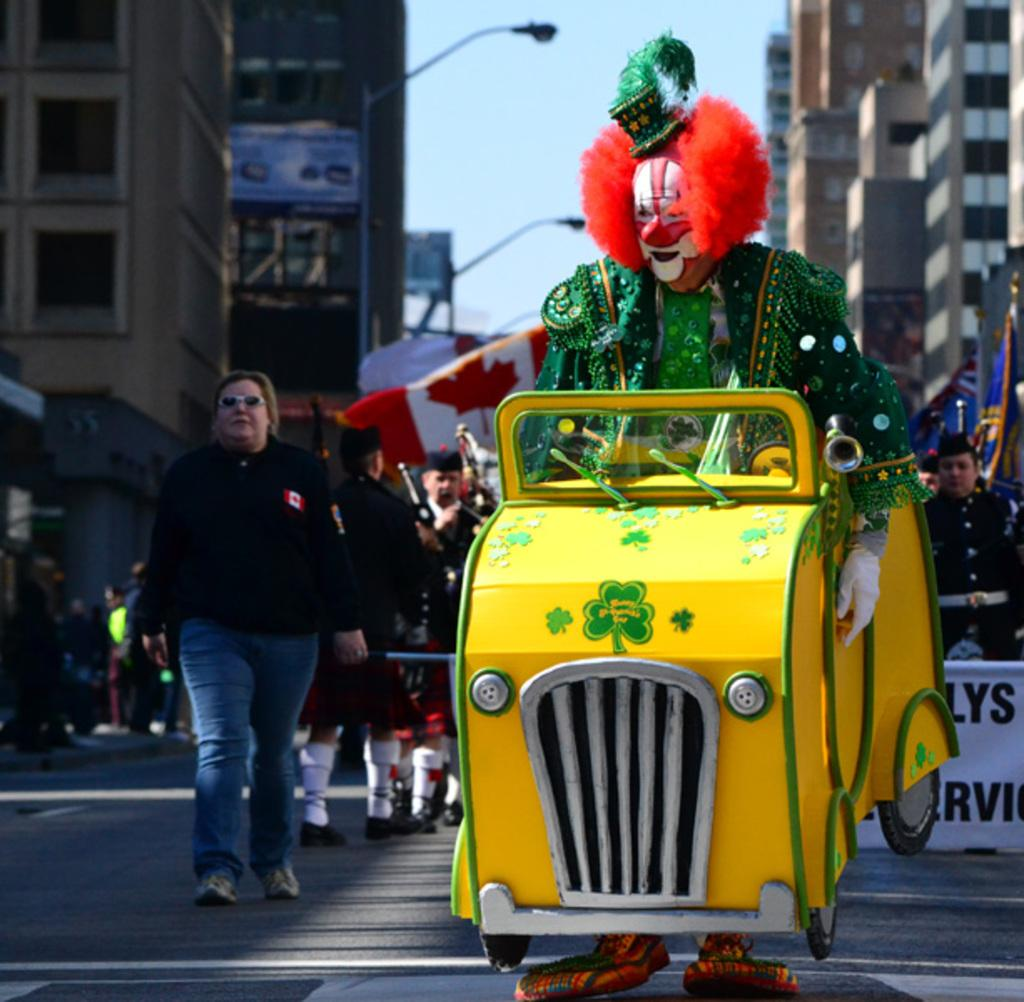Who or what can be seen in the image? There are people in the image. What type of vehicle is present in the image? There is a vehicle in the image. What additional feature can be seen in the image? There is a banner in the image. What type of structures are visible in the image? There are buildings in the image. What type of lighting is present in the image? There are street lamps in the image. What can be seen in the background of the image? The sky is visible in the image. Are there any bushes visible in the image? There is no mention of bushes in the provided facts, so we cannot determine if they are present in the image. What type of apparatus is being used by the people in the image? There is no apparatus mentioned in the provided facts, so we cannot determine if one is being used by the people in the image. 